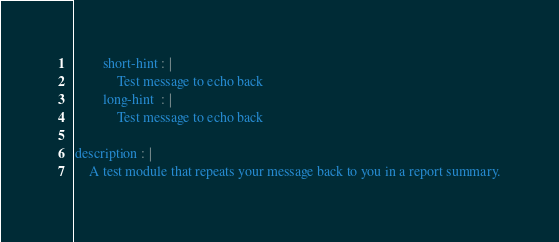<code> <loc_0><loc_0><loc_500><loc_500><_YAML_>        short-hint : |
            Test message to echo back
        long-hint  : |
            Test message to echo back

description : |
    A test module that repeats your message back to you in a report summary.
</code> 